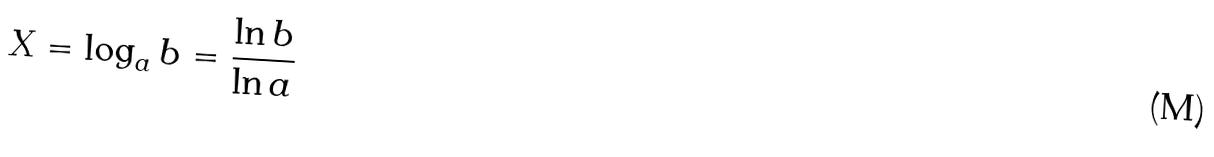Convert formula to latex. <formula><loc_0><loc_0><loc_500><loc_500>X = \log _ { a } b = \frac { \ln b } { \ln a }</formula> 